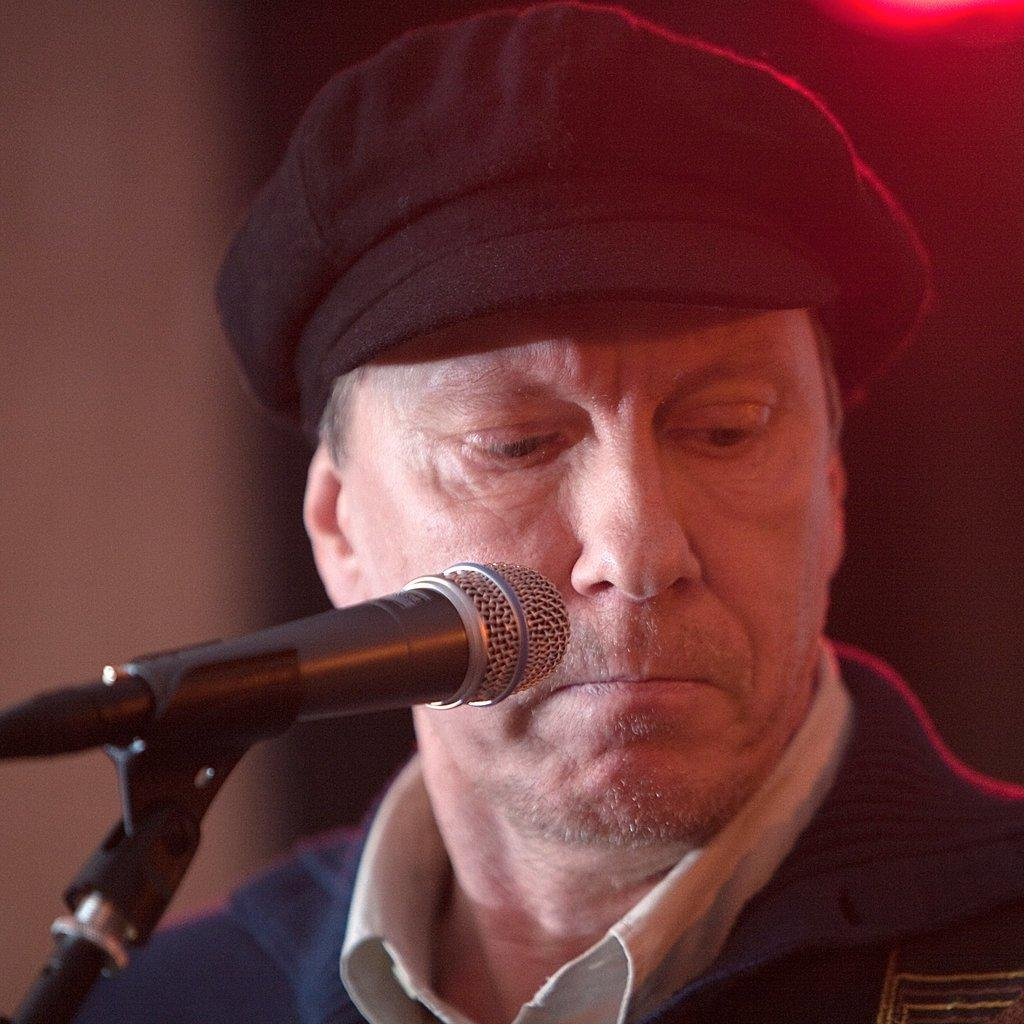What object is located in the bottom left side of the image? There is a microphone in the bottom left side of the image. Who is positioned near the microphone? A man is present behind the microphone. What type of territory is being claimed by the hen in the image? There is no hen present in the image, so no territory is being claimed. 